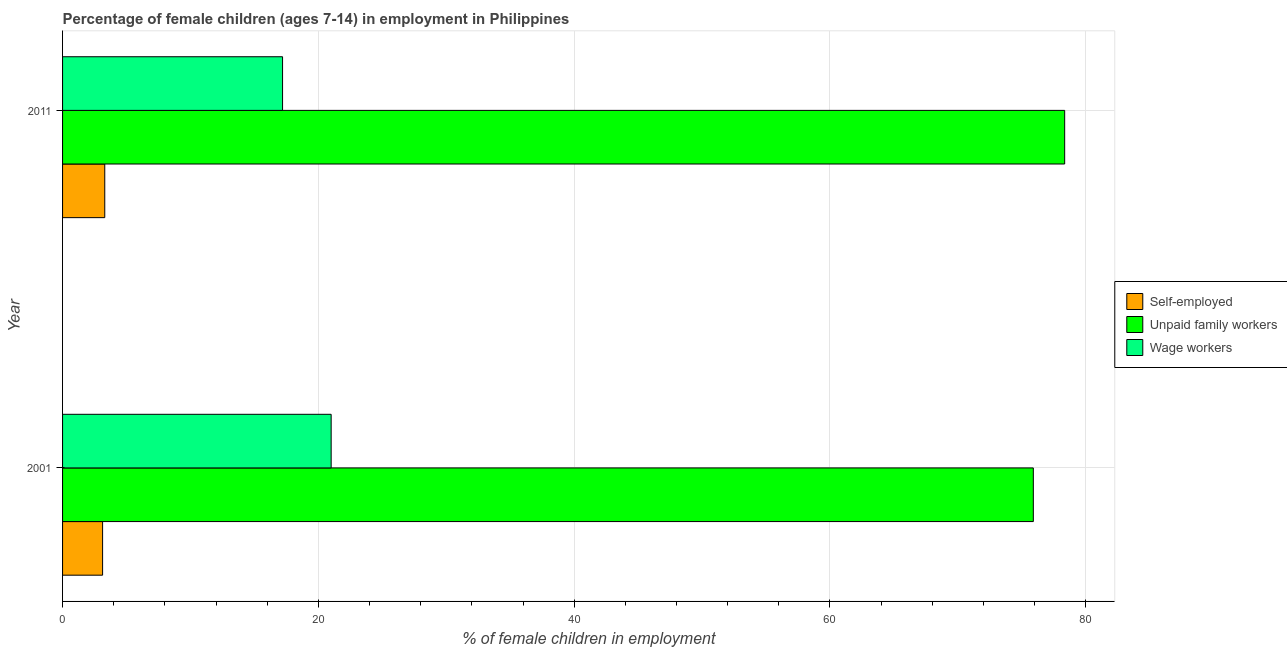How many different coloured bars are there?
Offer a terse response. 3. How many groups of bars are there?
Offer a very short reply. 2. Are the number of bars on each tick of the Y-axis equal?
Provide a succinct answer. Yes. How many bars are there on the 1st tick from the top?
Give a very brief answer. 3. How many bars are there on the 2nd tick from the bottom?
Offer a very short reply. 3. In how many cases, is the number of bars for a given year not equal to the number of legend labels?
Keep it short and to the point. 0. What is the percentage of children employed as wage workers in 2011?
Your answer should be very brief. 17.2. Across all years, what is the maximum percentage of children employed as unpaid family workers?
Keep it short and to the point. 78.35. Across all years, what is the minimum percentage of self employed children?
Offer a terse response. 3.13. What is the total percentage of children employed as wage workers in the graph?
Your response must be concise. 38.2. What is the difference between the percentage of self employed children in 2001 and that in 2011?
Make the answer very short. -0.17. What is the difference between the percentage of children employed as wage workers in 2001 and the percentage of children employed as unpaid family workers in 2011?
Give a very brief answer. -57.35. In the year 2001, what is the difference between the percentage of self employed children and percentage of children employed as wage workers?
Offer a terse response. -17.87. In how many years, is the percentage of children employed as unpaid family workers greater than 64 %?
Your answer should be very brief. 2. What is the ratio of the percentage of children employed as wage workers in 2001 to that in 2011?
Offer a terse response. 1.22. Is the percentage of self employed children in 2001 less than that in 2011?
Keep it short and to the point. Yes. In how many years, is the percentage of children employed as wage workers greater than the average percentage of children employed as wage workers taken over all years?
Give a very brief answer. 1. What does the 1st bar from the top in 2001 represents?
Give a very brief answer. Wage workers. What does the 1st bar from the bottom in 2001 represents?
Ensure brevity in your answer.  Self-employed. How many bars are there?
Ensure brevity in your answer.  6. How many years are there in the graph?
Ensure brevity in your answer.  2. What is the difference between two consecutive major ticks on the X-axis?
Ensure brevity in your answer.  20. Does the graph contain any zero values?
Your response must be concise. No. Does the graph contain grids?
Your answer should be very brief. Yes. Where does the legend appear in the graph?
Your answer should be compact. Center right. How are the legend labels stacked?
Your answer should be compact. Vertical. What is the title of the graph?
Your response must be concise. Percentage of female children (ages 7-14) in employment in Philippines. What is the label or title of the X-axis?
Offer a terse response. % of female children in employment. What is the label or title of the Y-axis?
Offer a very short reply. Year. What is the % of female children in employment in Self-employed in 2001?
Offer a very short reply. 3.13. What is the % of female children in employment of Unpaid family workers in 2001?
Your response must be concise. 75.9. What is the % of female children in employment of Wage workers in 2001?
Keep it short and to the point. 21. What is the % of female children in employment of Self-employed in 2011?
Your response must be concise. 3.3. What is the % of female children in employment of Unpaid family workers in 2011?
Your response must be concise. 78.35. Across all years, what is the maximum % of female children in employment of Unpaid family workers?
Provide a succinct answer. 78.35. Across all years, what is the maximum % of female children in employment in Wage workers?
Offer a very short reply. 21. Across all years, what is the minimum % of female children in employment in Self-employed?
Your answer should be very brief. 3.13. Across all years, what is the minimum % of female children in employment of Unpaid family workers?
Your answer should be very brief. 75.9. What is the total % of female children in employment of Self-employed in the graph?
Provide a succinct answer. 6.43. What is the total % of female children in employment of Unpaid family workers in the graph?
Keep it short and to the point. 154.25. What is the total % of female children in employment of Wage workers in the graph?
Offer a terse response. 38.2. What is the difference between the % of female children in employment in Self-employed in 2001 and that in 2011?
Offer a very short reply. -0.17. What is the difference between the % of female children in employment of Unpaid family workers in 2001 and that in 2011?
Provide a succinct answer. -2.45. What is the difference between the % of female children in employment of Wage workers in 2001 and that in 2011?
Make the answer very short. 3.8. What is the difference between the % of female children in employment in Self-employed in 2001 and the % of female children in employment in Unpaid family workers in 2011?
Give a very brief answer. -75.22. What is the difference between the % of female children in employment of Self-employed in 2001 and the % of female children in employment of Wage workers in 2011?
Your answer should be very brief. -14.07. What is the difference between the % of female children in employment in Unpaid family workers in 2001 and the % of female children in employment in Wage workers in 2011?
Give a very brief answer. 58.7. What is the average % of female children in employment in Self-employed per year?
Provide a succinct answer. 3.21. What is the average % of female children in employment of Unpaid family workers per year?
Provide a succinct answer. 77.12. What is the average % of female children in employment of Wage workers per year?
Offer a terse response. 19.1. In the year 2001, what is the difference between the % of female children in employment of Self-employed and % of female children in employment of Unpaid family workers?
Provide a succinct answer. -72.77. In the year 2001, what is the difference between the % of female children in employment in Self-employed and % of female children in employment in Wage workers?
Make the answer very short. -17.87. In the year 2001, what is the difference between the % of female children in employment of Unpaid family workers and % of female children in employment of Wage workers?
Keep it short and to the point. 54.9. In the year 2011, what is the difference between the % of female children in employment in Self-employed and % of female children in employment in Unpaid family workers?
Provide a short and direct response. -75.05. In the year 2011, what is the difference between the % of female children in employment in Self-employed and % of female children in employment in Wage workers?
Offer a very short reply. -13.9. In the year 2011, what is the difference between the % of female children in employment of Unpaid family workers and % of female children in employment of Wage workers?
Keep it short and to the point. 61.15. What is the ratio of the % of female children in employment in Self-employed in 2001 to that in 2011?
Keep it short and to the point. 0.95. What is the ratio of the % of female children in employment in Unpaid family workers in 2001 to that in 2011?
Provide a succinct answer. 0.97. What is the ratio of the % of female children in employment in Wage workers in 2001 to that in 2011?
Give a very brief answer. 1.22. What is the difference between the highest and the second highest % of female children in employment in Self-employed?
Your response must be concise. 0.17. What is the difference between the highest and the second highest % of female children in employment of Unpaid family workers?
Provide a short and direct response. 2.45. What is the difference between the highest and the lowest % of female children in employment in Self-employed?
Ensure brevity in your answer.  0.17. What is the difference between the highest and the lowest % of female children in employment of Unpaid family workers?
Your answer should be very brief. 2.45. What is the difference between the highest and the lowest % of female children in employment of Wage workers?
Provide a succinct answer. 3.8. 